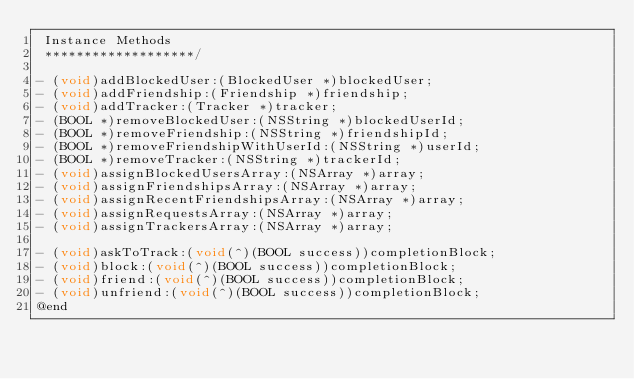<code> <loc_0><loc_0><loc_500><loc_500><_C_> Instance Methods
 *******************/

- (void)addBlockedUser:(BlockedUser *)blockedUser;
- (void)addFriendship:(Friendship *)friendship;
- (void)addTracker:(Tracker *)tracker;
- (BOOL *)removeBlockedUser:(NSString *)blockedUserId;
- (BOOL *)removeFriendship:(NSString *)friendshipId;
- (BOOL *)removeFriendshipWithUserId:(NSString *)userId;
- (BOOL *)removeTracker:(NSString *)trackerId;
- (void)assignBlockedUsersArray:(NSArray *)array;
- (void)assignFriendshipsArray:(NSArray *)array;
- (void)assignRecentFriendshipsArray:(NSArray *)array;
- (void)assignRequestsArray:(NSArray *)array;
- (void)assignTrackersArray:(NSArray *)array;

- (void)askToTrack:(void(^)(BOOL success))completionBlock;
- (void)block:(void(^)(BOOL success))completionBlock;
- (void)friend:(void(^)(BOOL success))completionBlock;
- (void)unfriend:(void(^)(BOOL success))completionBlock;
@end
</code> 